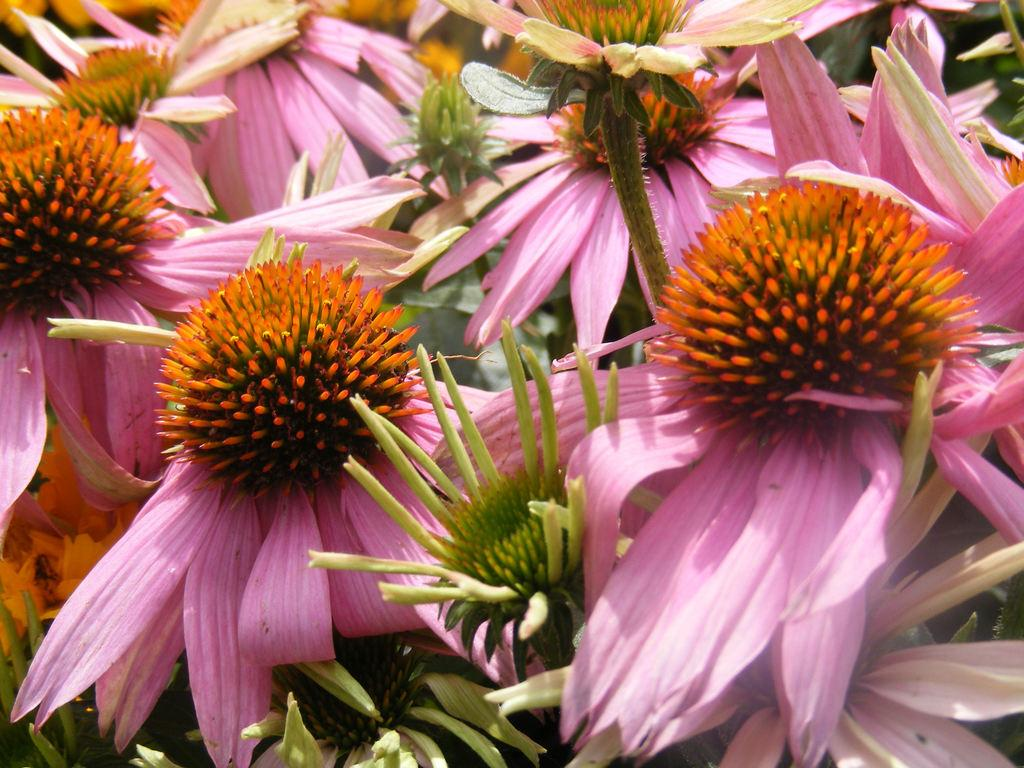What type of living organisms can be seen in the image? Flowers can be seen in the image. Can you tell me how many pickles are hidden among the flowers in the image? There are no pickles present in the image; it features only flowers. What type of footwear is visible in the image? There is no footwear visible in the image; it only contains flowers. 